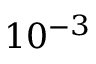Convert formula to latex. <formula><loc_0><loc_0><loc_500><loc_500>1 0 ^ { - 3 }</formula> 